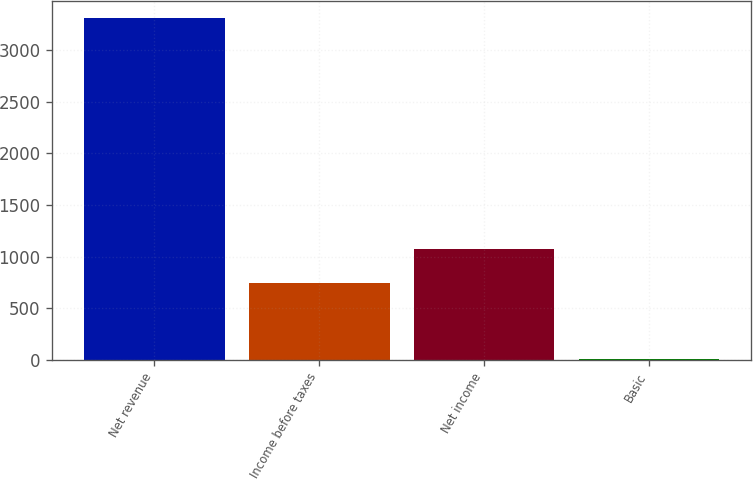<chart> <loc_0><loc_0><loc_500><loc_500><bar_chart><fcel>Net revenue<fcel>Income before taxes<fcel>Net income<fcel>Basic<nl><fcel>3315<fcel>746<fcel>1077<fcel>5.04<nl></chart> 